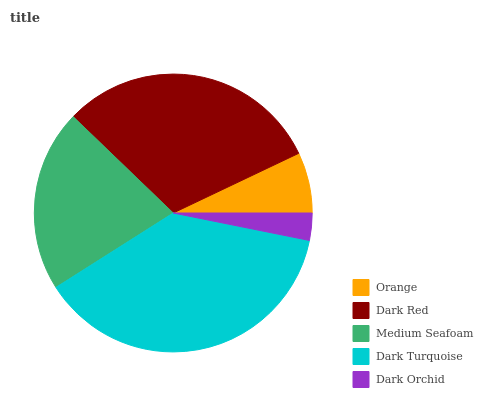Is Dark Orchid the minimum?
Answer yes or no. Yes. Is Dark Turquoise the maximum?
Answer yes or no. Yes. Is Dark Red the minimum?
Answer yes or no. No. Is Dark Red the maximum?
Answer yes or no. No. Is Dark Red greater than Orange?
Answer yes or no. Yes. Is Orange less than Dark Red?
Answer yes or no. Yes. Is Orange greater than Dark Red?
Answer yes or no. No. Is Dark Red less than Orange?
Answer yes or no. No. Is Medium Seafoam the high median?
Answer yes or no. Yes. Is Medium Seafoam the low median?
Answer yes or no. Yes. Is Orange the high median?
Answer yes or no. No. Is Dark Turquoise the low median?
Answer yes or no. No. 